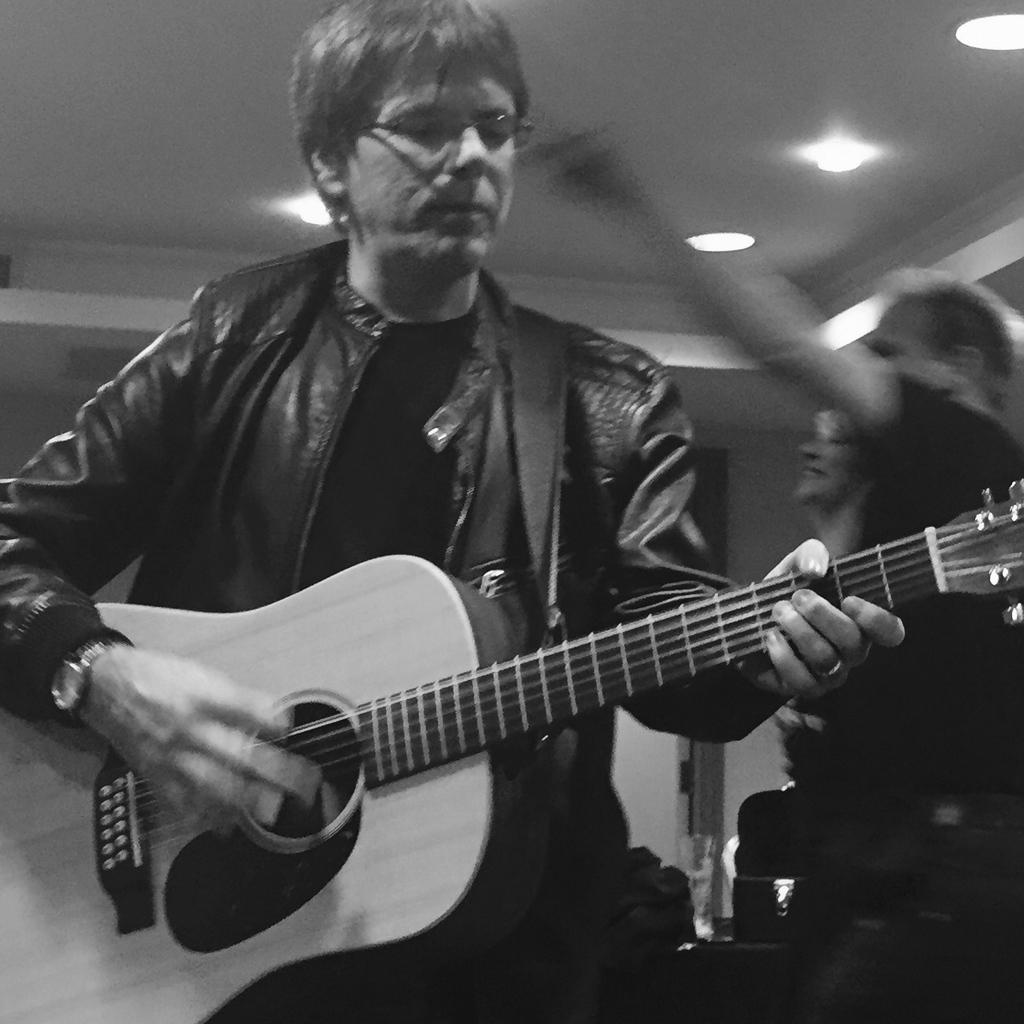What is the main subject of the image? The main subject of the image is a man. What is the man holding in the image? The man is holding a guitar. What type of cave can be seen in the background of the image? There is no cave present in the image; it features a man holding a guitar. How many beams are visible in the image? There are no beams visible in the image. 